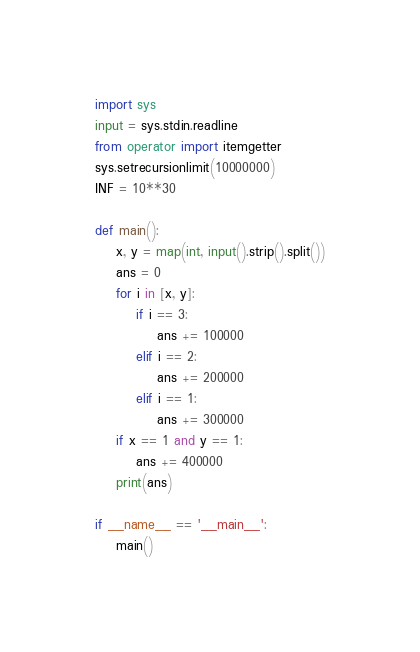<code> <loc_0><loc_0><loc_500><loc_500><_Python_>import sys
input = sys.stdin.readline
from operator import itemgetter
sys.setrecursionlimit(10000000)
INF = 10**30

def main():
    x, y = map(int, input().strip().split())
    ans = 0
    for i in [x, y]:
        if i == 3:
            ans += 100000
        elif i == 2:
            ans += 200000
        elif i == 1:
            ans += 300000
    if x == 1 and y == 1:
        ans += 400000
    print(ans)

if __name__ == '__main__':
    main()
</code> 